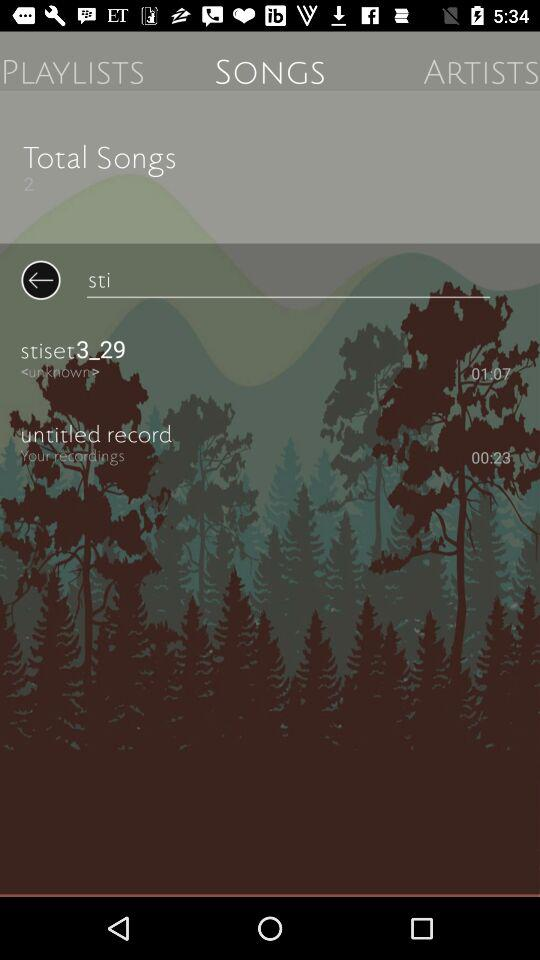Which tab is selected? The selected tab is "SONGS". 